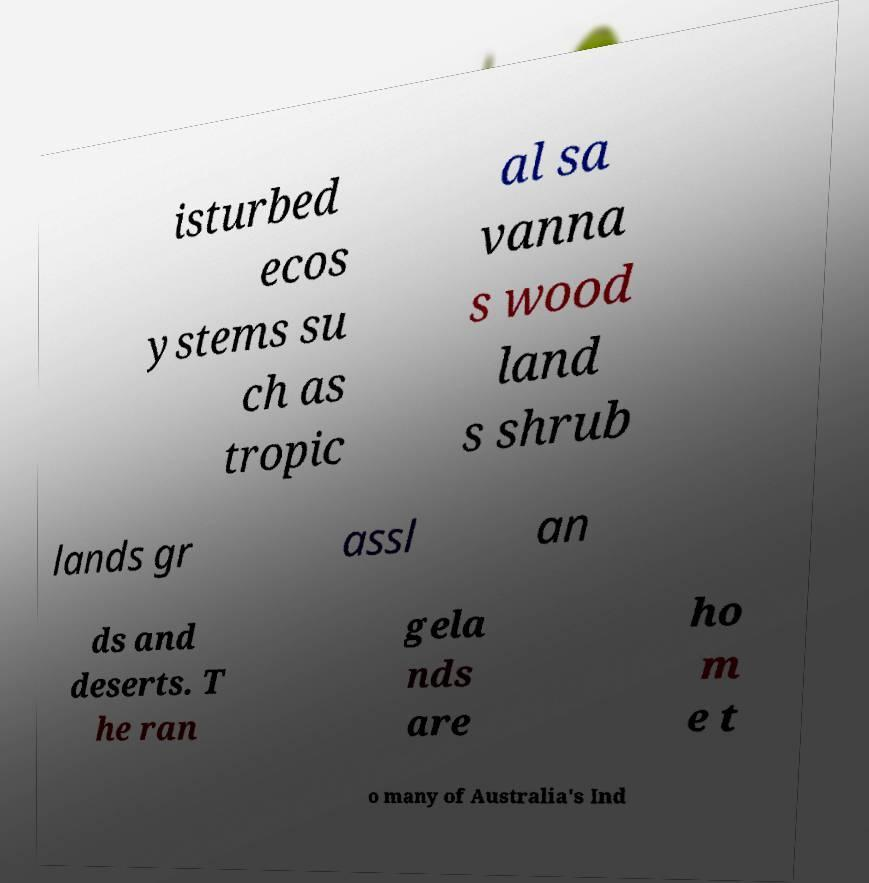Please identify and transcribe the text found in this image. isturbed ecos ystems su ch as tropic al sa vanna s wood land s shrub lands gr assl an ds and deserts. T he ran gela nds are ho m e t o many of Australia's Ind 